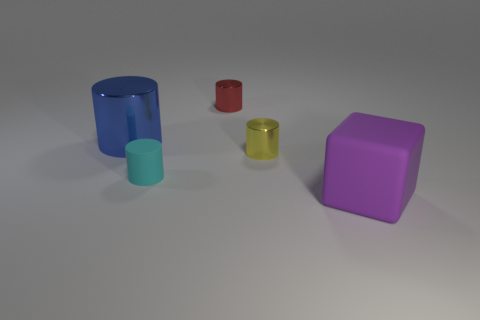How many other things are the same shape as the tiny yellow thing?
Keep it short and to the point. 3. Are there the same number of big metallic cylinders in front of the tiny matte thing and red objects that are on the right side of the purple cube?
Offer a terse response. Yes. Is there a large cylinder?
Give a very brief answer. Yes. There is a metal cylinder that is behind the large object that is to the left of the rubber thing to the right of the red metallic object; what is its size?
Your answer should be compact. Small. The object that is the same size as the blue cylinder is what shape?
Your answer should be compact. Cube. Is there any other thing that is the same material as the small yellow thing?
Provide a short and direct response. Yes. What number of things are things that are in front of the large blue thing or large blue metallic objects?
Your answer should be very brief. 4. There is a big object behind the large thing in front of the cyan cylinder; are there any big purple matte cubes to the left of it?
Give a very brief answer. No. What number of small things are there?
Offer a terse response. 3. How many things are objects that are on the right side of the big shiny cylinder or small metallic cylinders that are behind the large blue metallic cylinder?
Your answer should be compact. 4. 